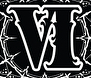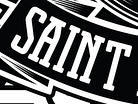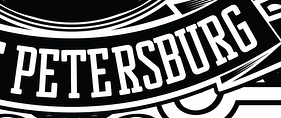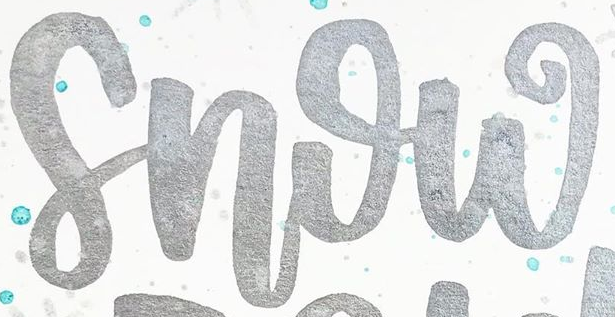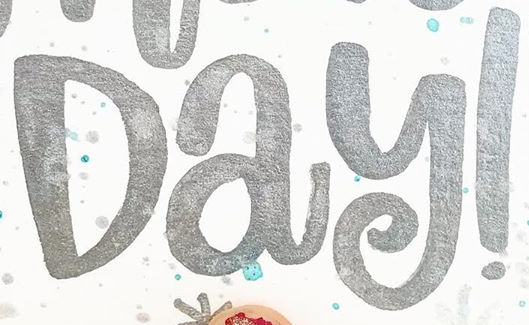What words are shown in these images in order, separated by a semicolon? VI; SAINT; PETERSBURG; Snow; Day! 